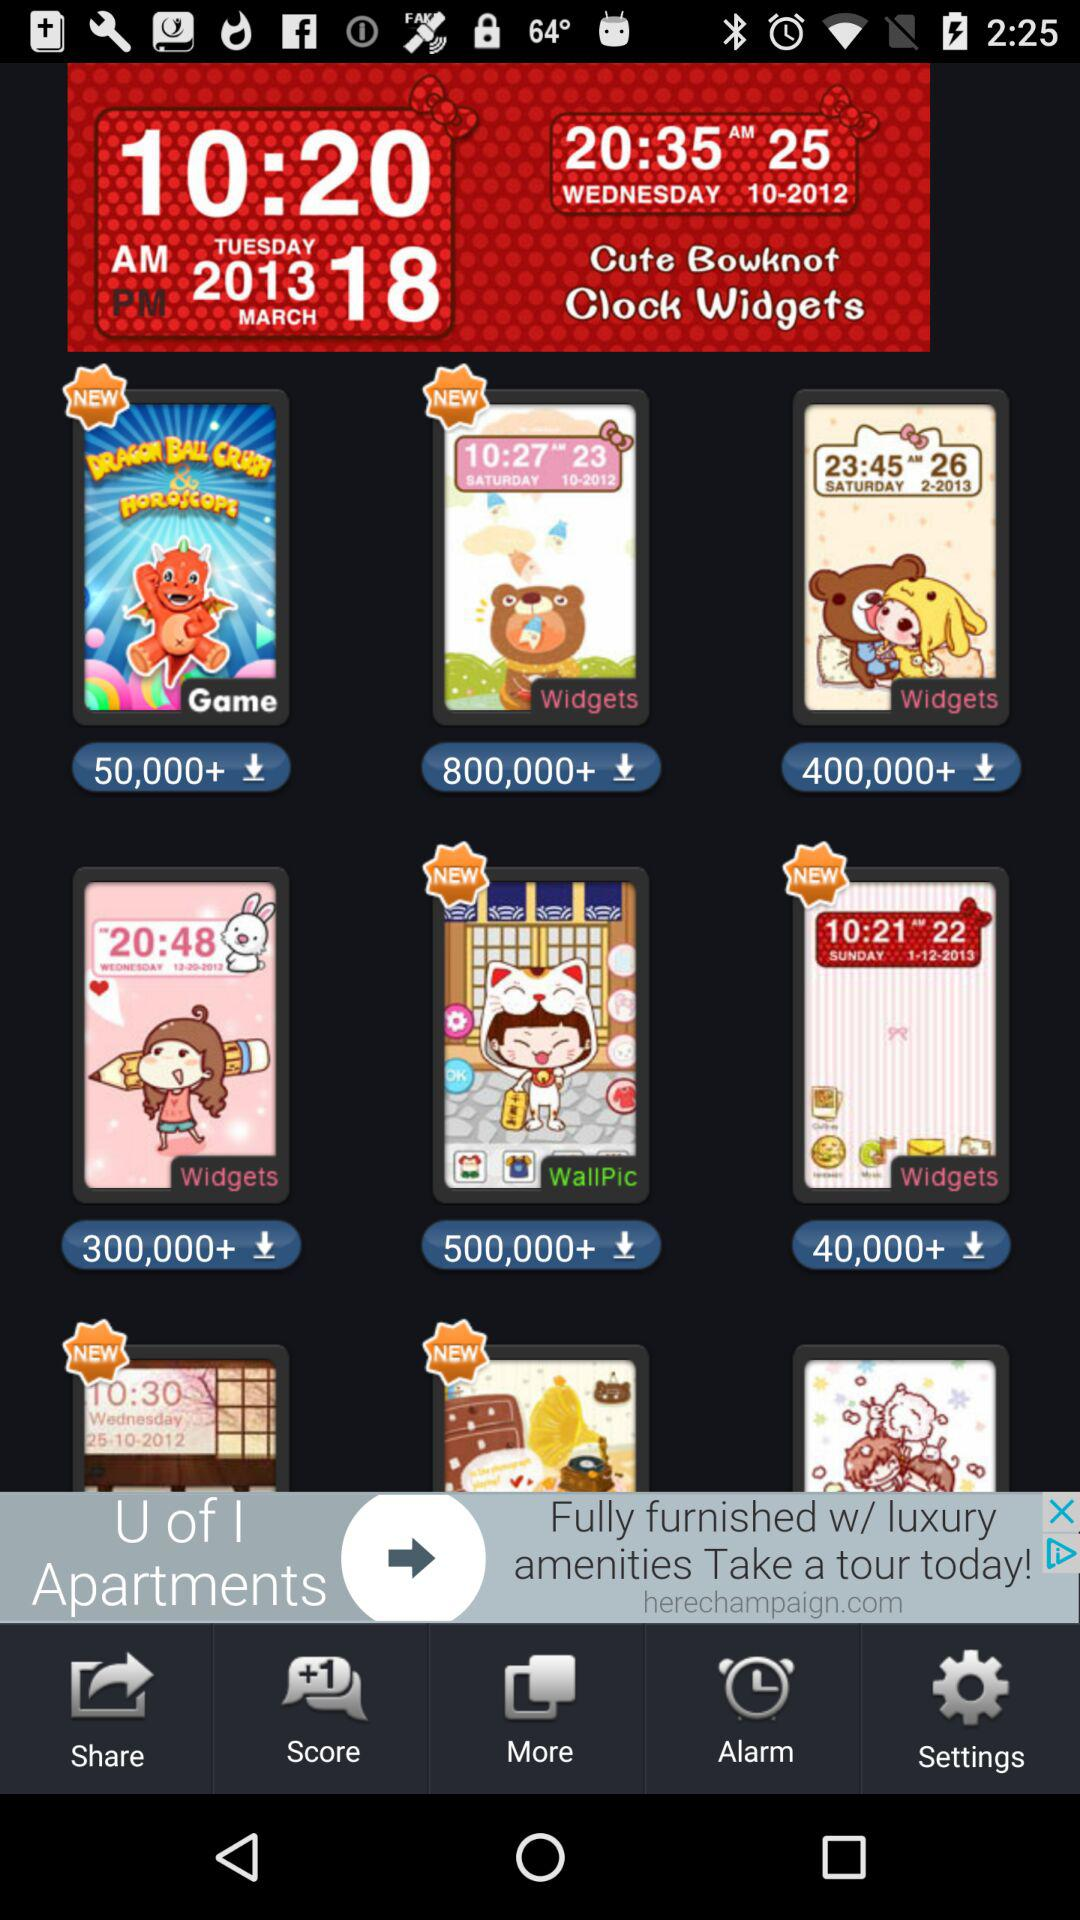What is the name of the application?
When the provided information is insufficient, respond with <no answer>. <no answer> 